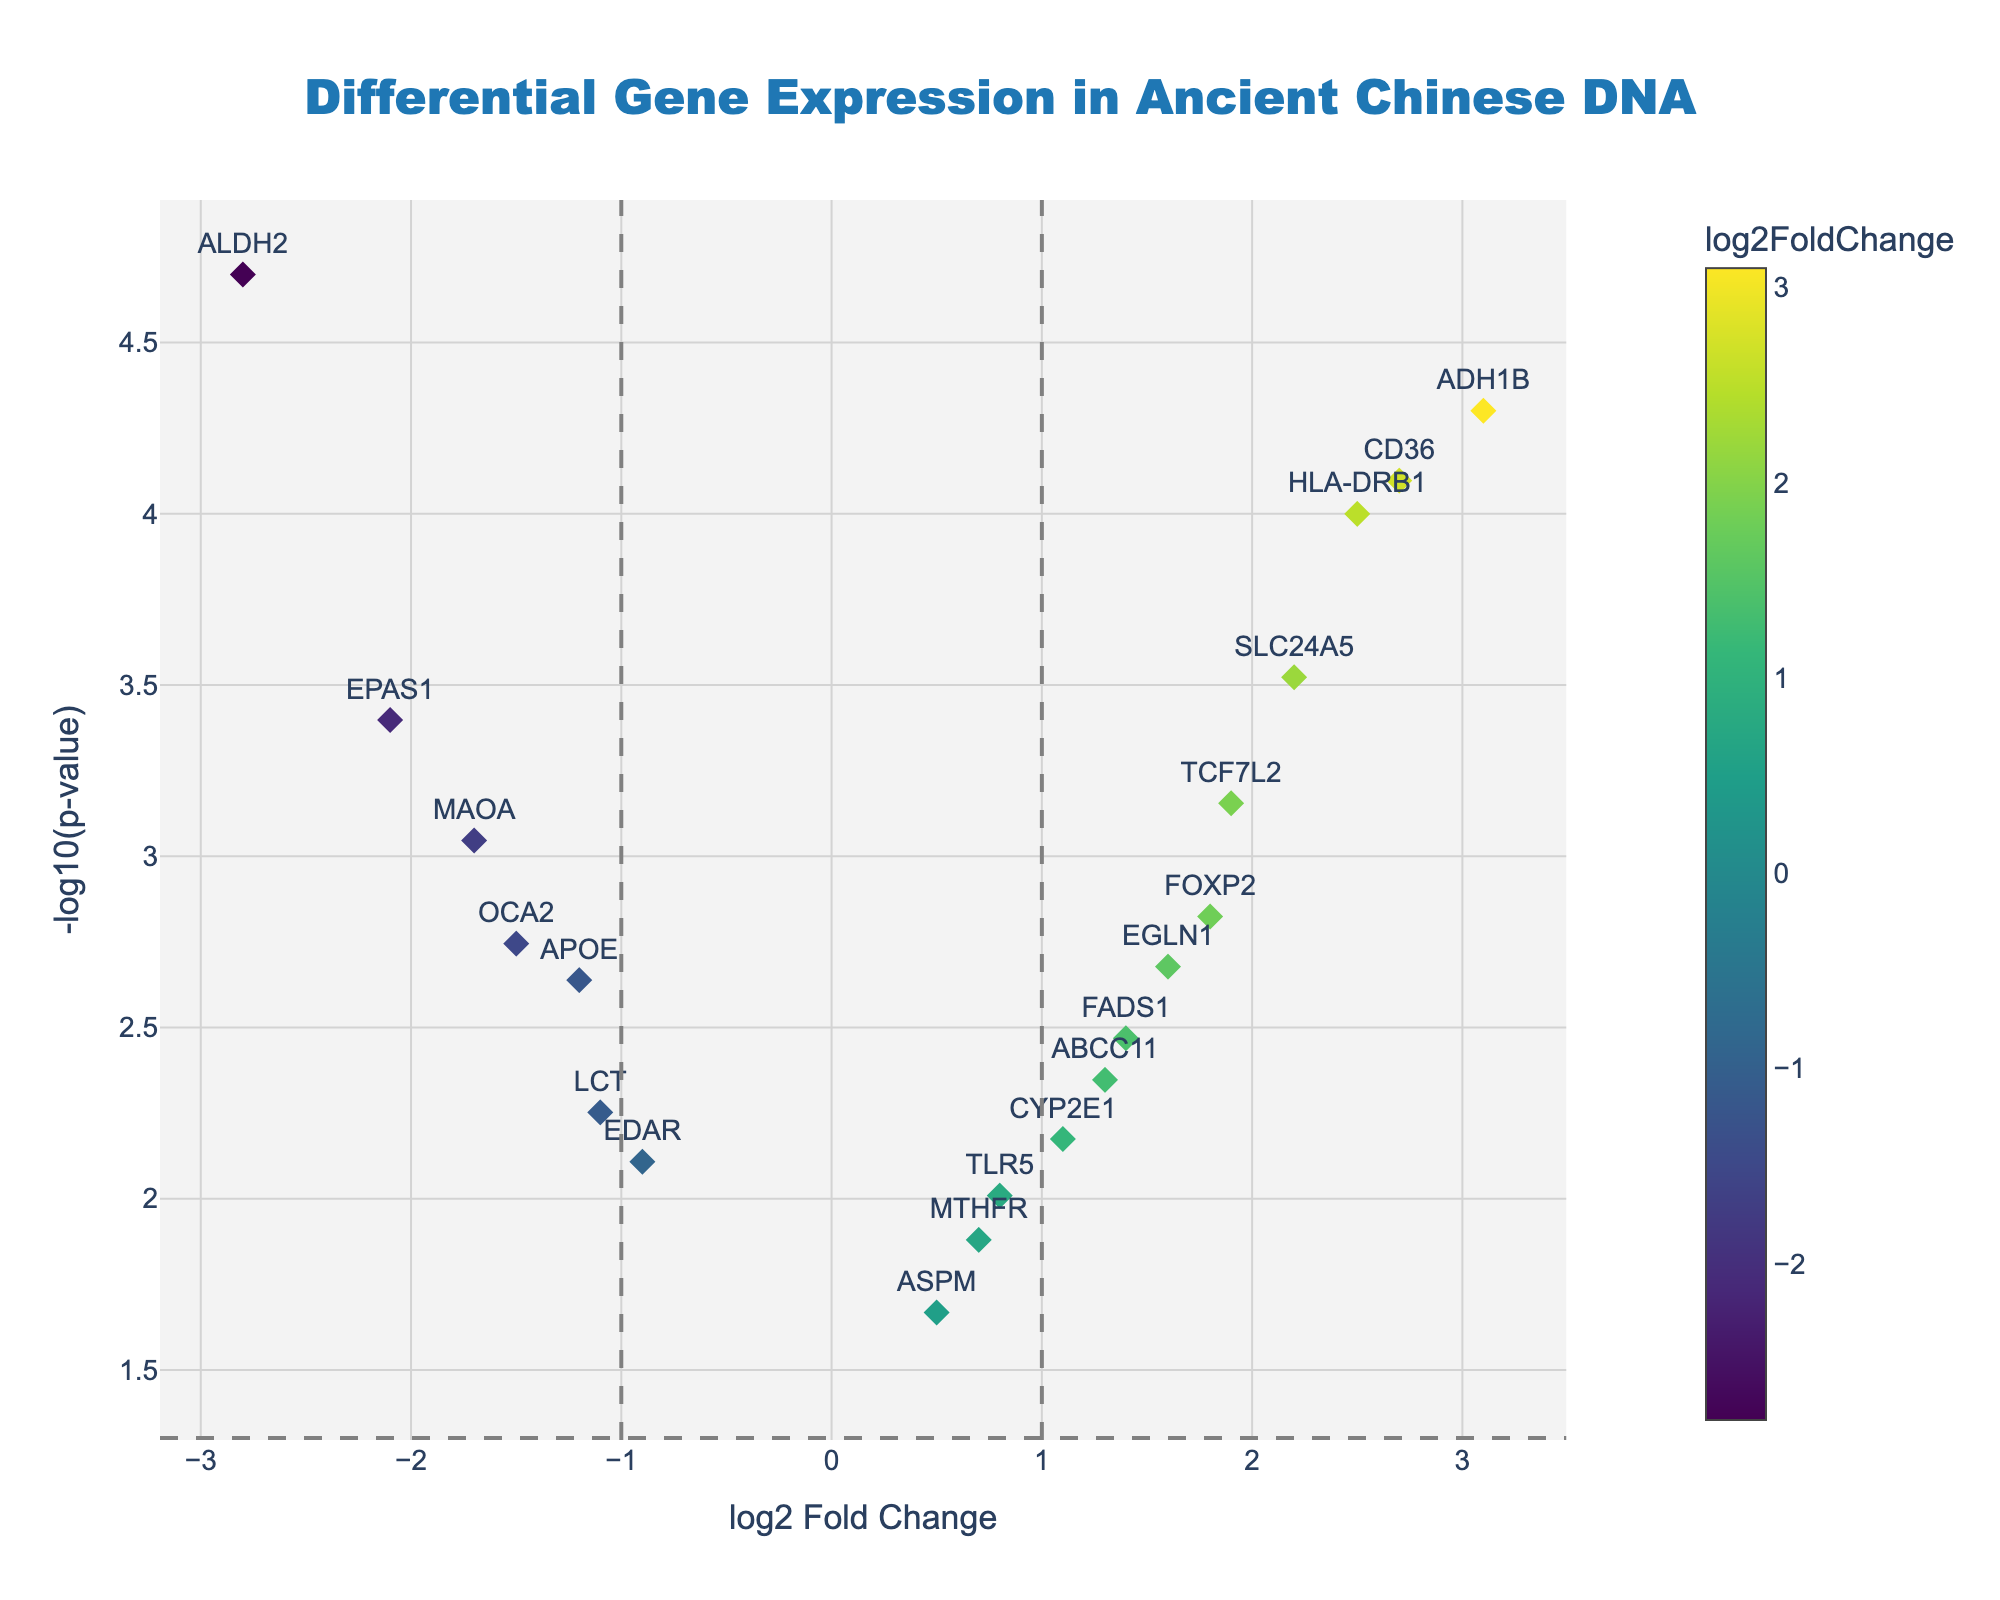what is the title of the plot? The title is located at the top center of the plot and provides a quick summary of the content. In this case, it states "Differential Gene Expression in Ancient Chinese DNA."
Answer: Differential Gene Expression in Ancient Chinese DNA how many genes have a log2 fold change greater than 2? By examining the x-axis, which represents the log2 fold change, we count the number of data points to the right of the value 2. The genes are APOE, ADH1B, CD36, and SLC24A5.
Answer: 4 which gene has the lowest p-value? The p-value is reflected on the y-axis as -log10(p-value). The gene with the highest y-axis value has the lowest p-value. In this plot, ALDH2 has the highest -log10(p-value), making it the gene with the lowest p-value.
Answer: ALDH2 which gene has the highest log2 fold change? By checking the farthest point to the right along the x-axis, which represents log2 fold change, we find ADH1B has the highest value.
Answer: ADH1B how many genes have a p-value less than 0.05? On the y-axis, -log10(p-value) greater than -log10(0.05) means a p-value less than 0.05. Count all data points above the horizontal line, which is 15.
Answer: 15 which gene has the lowest log2 fold change? By examining the farthest point to the left along the x-axis, representing the log2 fold change, we identify ALDH2 has the lowest value.
Answer: ALDH2 which genes are located in quadrants with log2 fold change between -1 and 1 and p-value greater than 0.05? Quadrants between -1 and 1 log2 fold change are considered stable expression. A p-value greater than 0.05 is considered not statistically significant. Only genes ASPM and MTHFR fall within this range.
Answer: ASPM, MTHFR which gene has the highest significance but minimal change in log2 fold change? A high significance is indicated by a large -log10(p-value), and minimal change is log2 fold close to zero. ASPM, with a high -log10(p-value) and near-zero log2 fold change, best matches these criteria.
Answer: ASPM how many genes exhibit downregulation with significant p-values? Downregulation is represented by negative log2 fold change values. Significant p-values are indicated by y-values above the threshold line for -log10(0.05). The genes are APOE, EDAR, OCA2, ALDH2, LCT, and EPAS1.
Answer: 6 